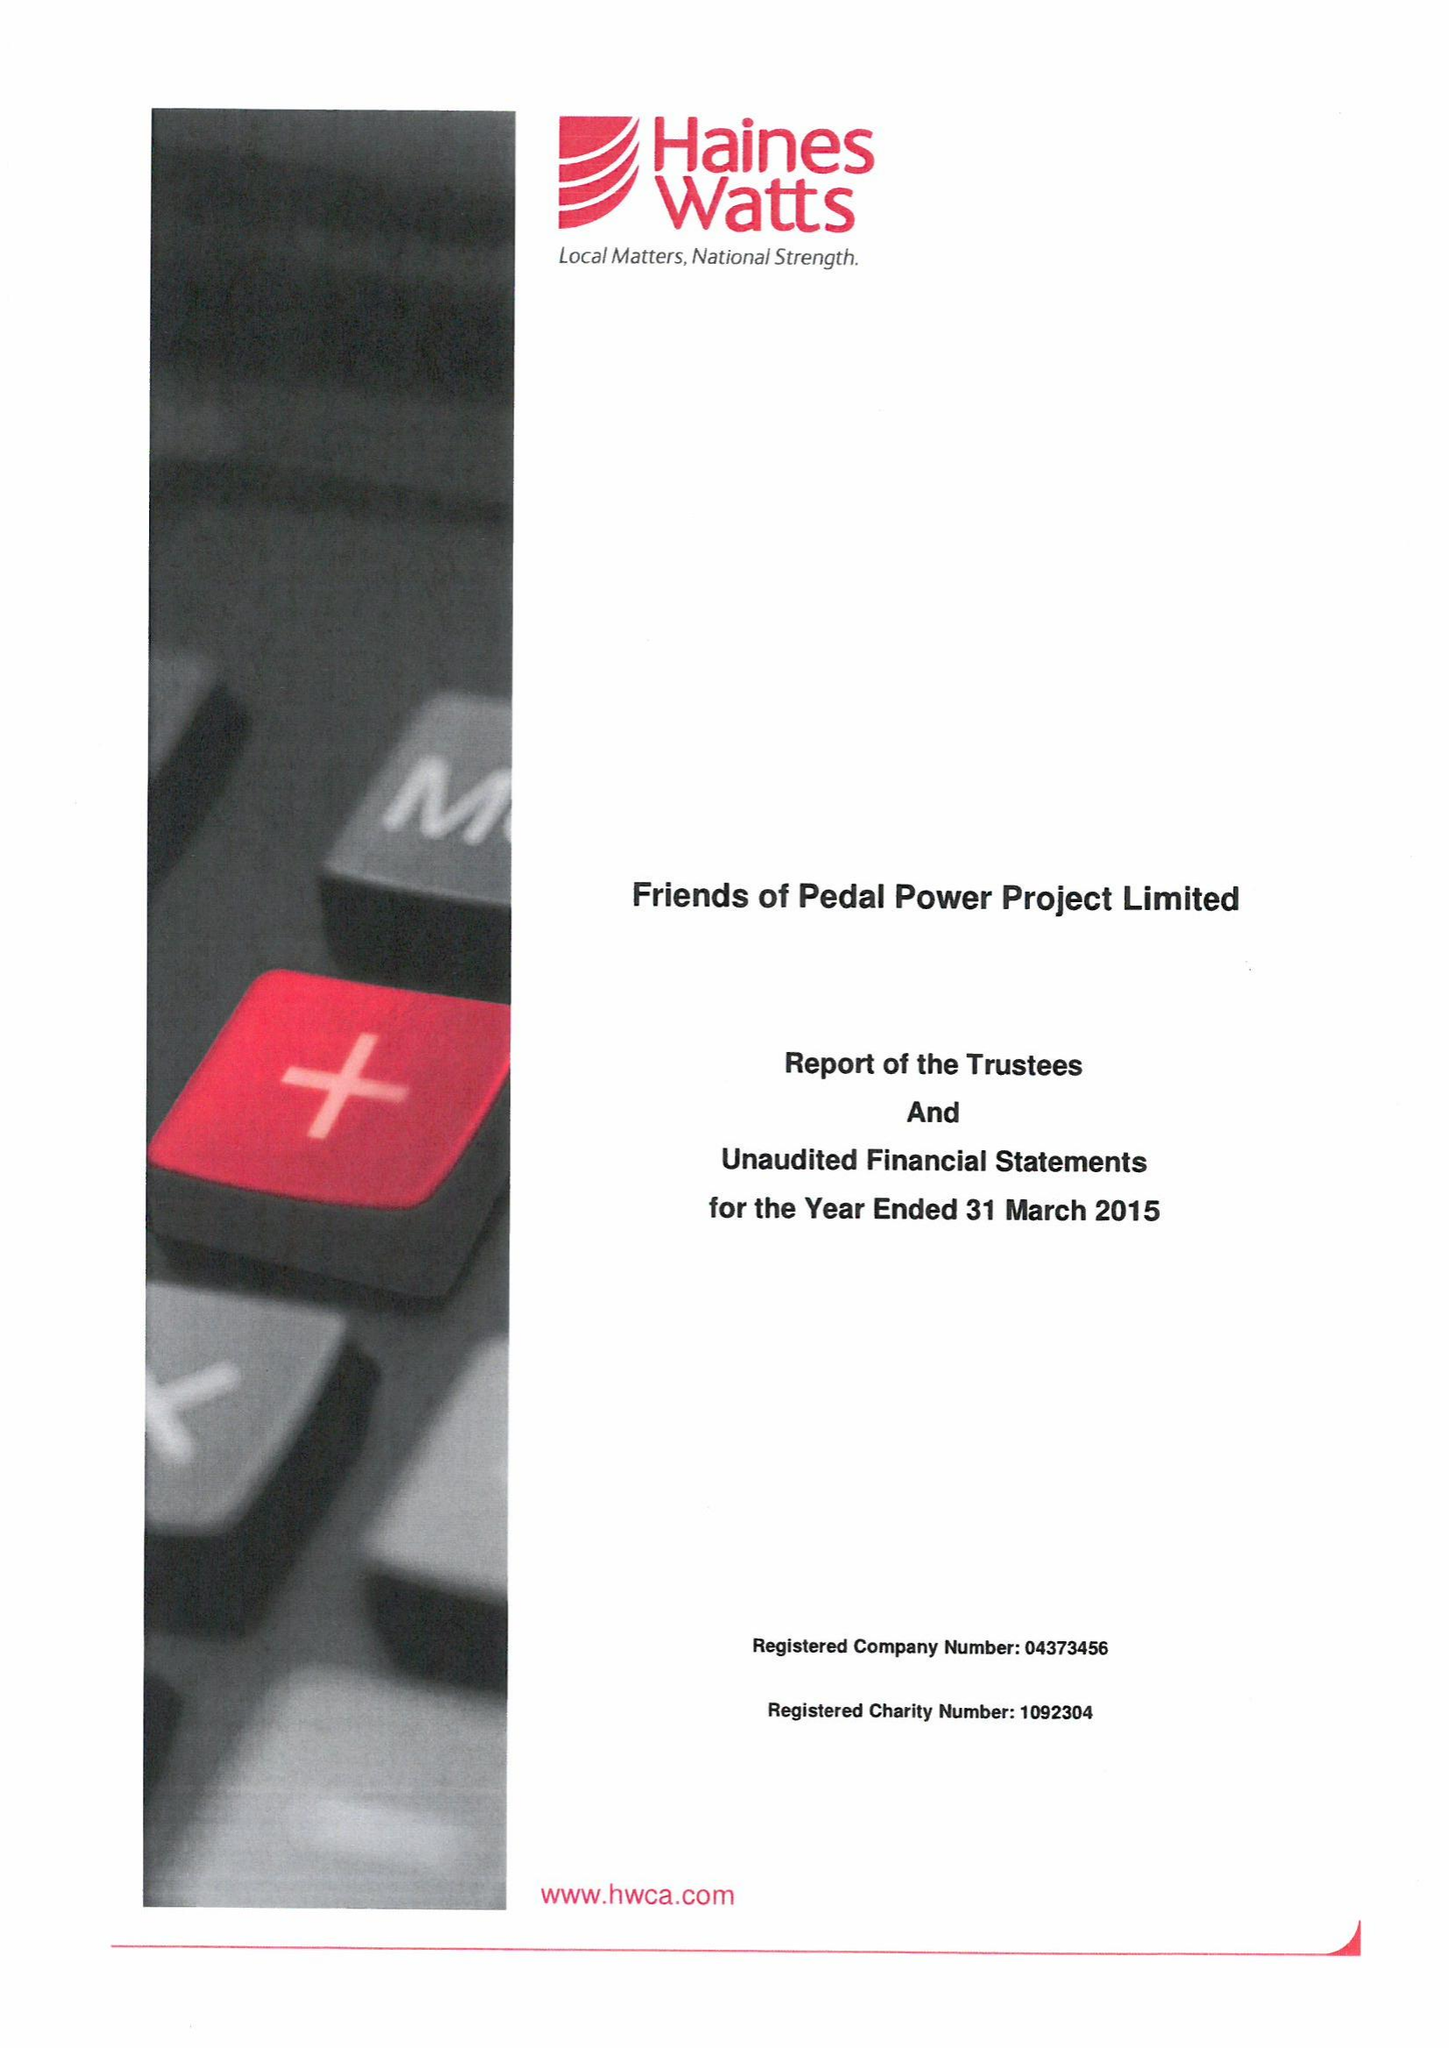What is the value for the charity_name?
Answer the question using a single word or phrase. Friends Of Pedal Power Project Ltd. 